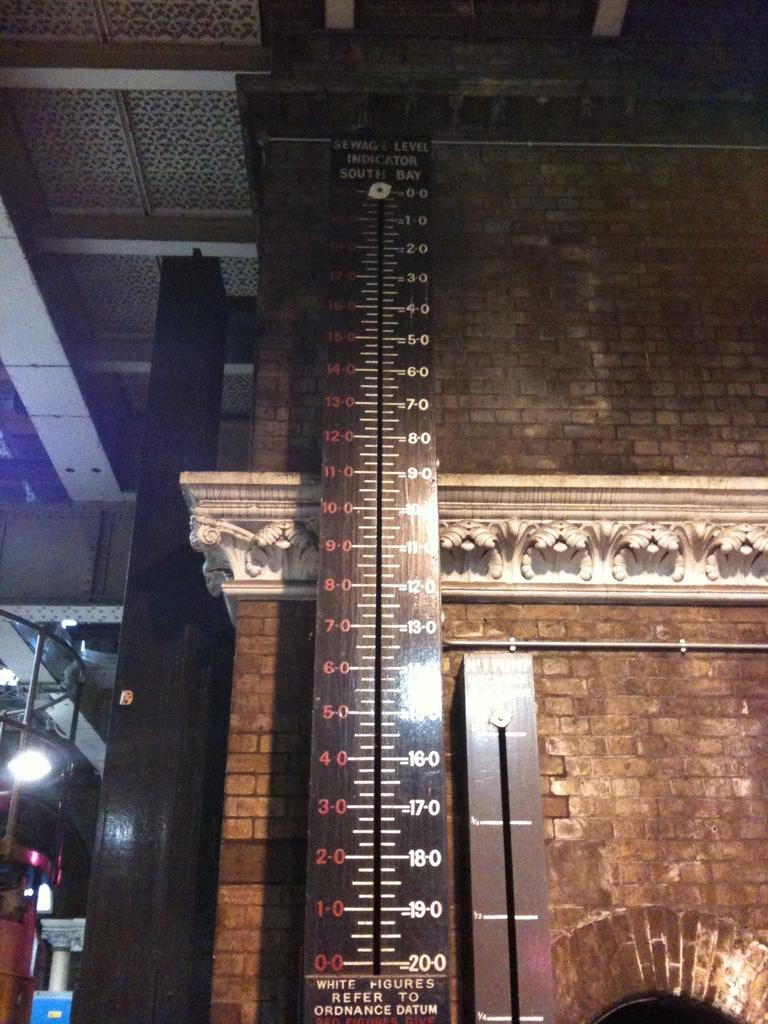What is the main object in the center of the image? There is a scale in the center of the image. What can be seen in the distance behind the scale? There are buildings in the background of the image. What is on the left side of the image? There is a railing, lights, and other objects on the left side of the image. What type of birthday celebration is taking place in the image? There is no birthday celebration present in the image. What account information can be seen on the scale in the image? There is no account information present on the scale in the image. 